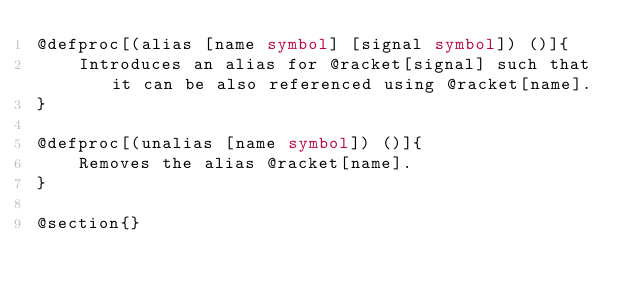<code> <loc_0><loc_0><loc_500><loc_500><_Racket_>@defproc[(alias [name symbol] [signal symbol]) ()]{
    Introduces an alias for @racket[signal] such that it can be also referenced using @racket[name]. 
}

@defproc[(unalias [name symbol]) ()]{
    Removes the alias @racket[name].
}

@section{}

</code> 